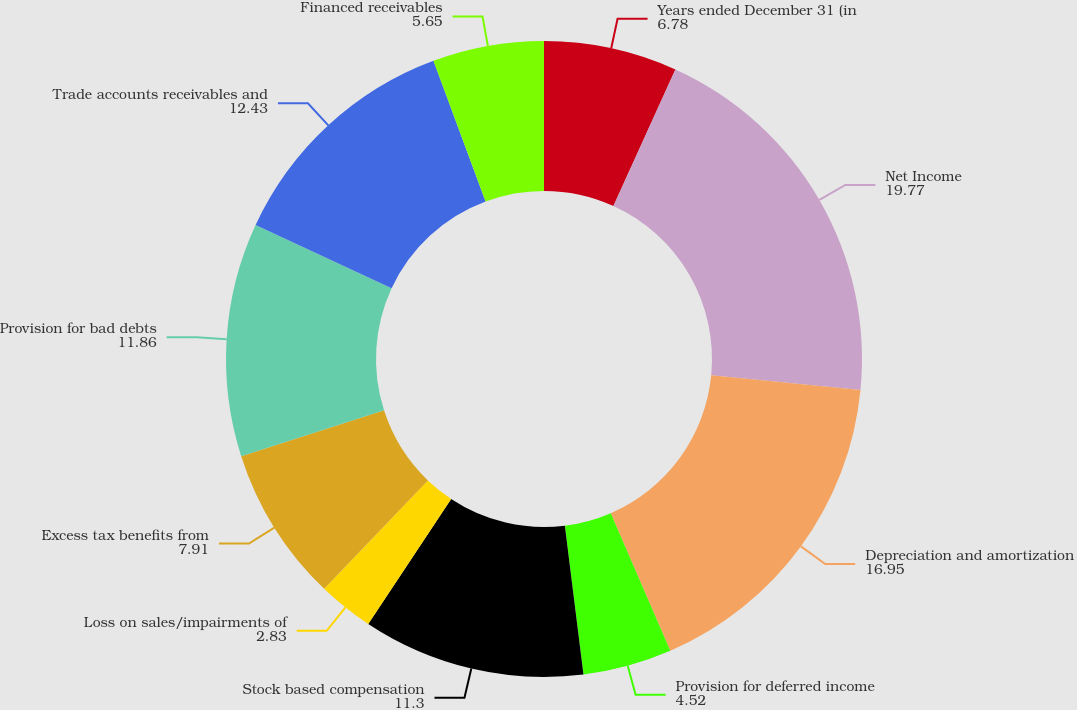Convert chart. <chart><loc_0><loc_0><loc_500><loc_500><pie_chart><fcel>Years ended December 31 (in<fcel>Net Income<fcel>Depreciation and amortization<fcel>Provision for deferred income<fcel>Stock based compensation<fcel>Loss on sales/impairments of<fcel>Excess tax benefits from<fcel>Provision for bad debts<fcel>Trade accounts receivables and<fcel>Financed receivables<nl><fcel>6.78%<fcel>19.77%<fcel>16.95%<fcel>4.52%<fcel>11.3%<fcel>2.83%<fcel>7.91%<fcel>11.86%<fcel>12.43%<fcel>5.65%<nl></chart> 